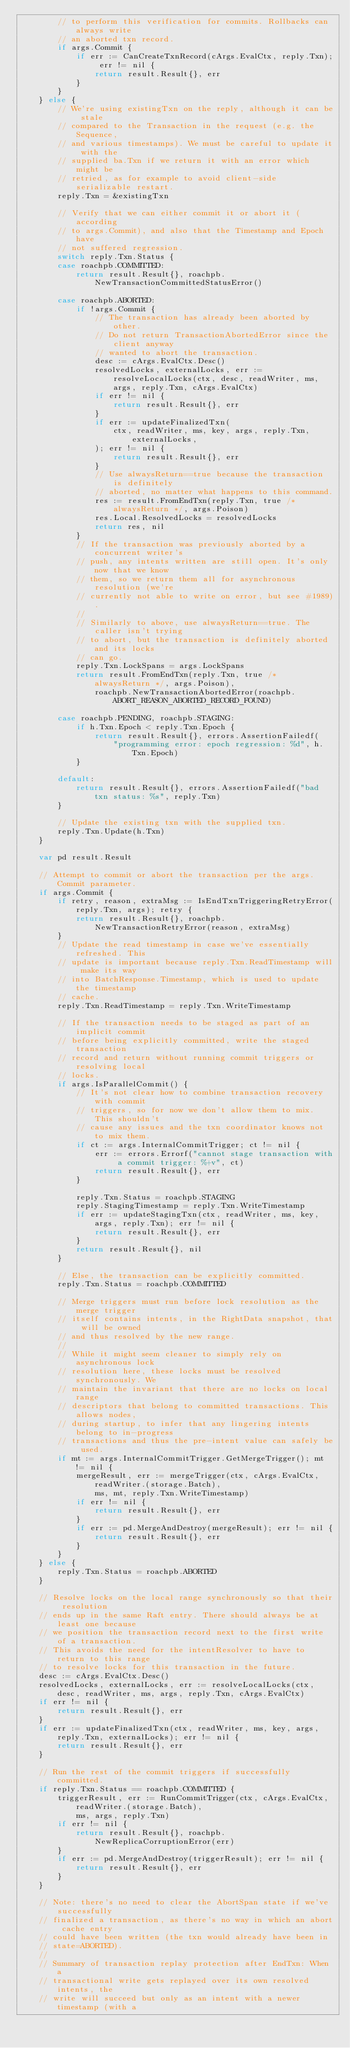<code> <loc_0><loc_0><loc_500><loc_500><_Go_>		// to perform this verification for commits. Rollbacks can always write
		// an aborted txn record.
		if args.Commit {
			if err := CanCreateTxnRecord(cArgs.EvalCtx, reply.Txn); err != nil {
				return result.Result{}, err
			}
		}
	} else {
		// We're using existingTxn on the reply, although it can be stale
		// compared to the Transaction in the request (e.g. the Sequence,
		// and various timestamps). We must be careful to update it with the
		// supplied ba.Txn if we return it with an error which might be
		// retried, as for example to avoid client-side serializable restart.
		reply.Txn = &existingTxn

		// Verify that we can either commit it or abort it (according
		// to args.Commit), and also that the Timestamp and Epoch have
		// not suffered regression.
		switch reply.Txn.Status {
		case roachpb.COMMITTED:
			return result.Result{}, roachpb.NewTransactionCommittedStatusError()

		case roachpb.ABORTED:
			if !args.Commit {
				// The transaction has already been aborted by other.
				// Do not return TransactionAbortedError since the client anyway
				// wanted to abort the transaction.
				desc := cArgs.EvalCtx.Desc()
				resolvedLocks, externalLocks, err := resolveLocalLocks(ctx, desc, readWriter, ms, args, reply.Txn, cArgs.EvalCtx)
				if err != nil {
					return result.Result{}, err
				}
				if err := updateFinalizedTxn(
					ctx, readWriter, ms, key, args, reply.Txn, externalLocks,
				); err != nil {
					return result.Result{}, err
				}
				// Use alwaysReturn==true because the transaction is definitely
				// aborted, no matter what happens to this command.
				res := result.FromEndTxn(reply.Txn, true /* alwaysReturn */, args.Poison)
				res.Local.ResolvedLocks = resolvedLocks
				return res, nil
			}
			// If the transaction was previously aborted by a concurrent writer's
			// push, any intents written are still open. It's only now that we know
			// them, so we return them all for asynchronous resolution (we're
			// currently not able to write on error, but see #1989).
			//
			// Similarly to above, use alwaysReturn==true. The caller isn't trying
			// to abort, but the transaction is definitely aborted and its locks
			// can go.
			reply.Txn.LockSpans = args.LockSpans
			return result.FromEndTxn(reply.Txn, true /* alwaysReturn */, args.Poison),
				roachpb.NewTransactionAbortedError(roachpb.ABORT_REASON_ABORTED_RECORD_FOUND)

		case roachpb.PENDING, roachpb.STAGING:
			if h.Txn.Epoch < reply.Txn.Epoch {
				return result.Result{}, errors.AssertionFailedf(
					"programming error: epoch regression: %d", h.Txn.Epoch)
			}

		default:
			return result.Result{}, errors.AssertionFailedf("bad txn status: %s", reply.Txn)
		}

		// Update the existing txn with the supplied txn.
		reply.Txn.Update(h.Txn)
	}

	var pd result.Result

	// Attempt to commit or abort the transaction per the args.Commit parameter.
	if args.Commit {
		if retry, reason, extraMsg := IsEndTxnTriggeringRetryError(reply.Txn, args); retry {
			return result.Result{}, roachpb.NewTransactionRetryError(reason, extraMsg)
		}
		// Update the read timestamp in case we've essentially refreshed. This
		// update is important because reply.Txn.ReadTimestamp will make its way
		// into BatchResponse.Timestamp, which is used to update the timestamp
		// cache.
		reply.Txn.ReadTimestamp = reply.Txn.WriteTimestamp

		// If the transaction needs to be staged as part of an implicit commit
		// before being explicitly committed, write the staged transaction
		// record and return without running commit triggers or resolving local
		// locks.
		if args.IsParallelCommit() {
			// It's not clear how to combine transaction recovery with commit
			// triggers, so for now we don't allow them to mix. This shouldn't
			// cause any issues and the txn coordinator knows not to mix them.
			if ct := args.InternalCommitTrigger; ct != nil {
				err := errors.Errorf("cannot stage transaction with a commit trigger: %+v", ct)
				return result.Result{}, err
			}

			reply.Txn.Status = roachpb.STAGING
			reply.StagingTimestamp = reply.Txn.WriteTimestamp
			if err := updateStagingTxn(ctx, readWriter, ms, key, args, reply.Txn); err != nil {
				return result.Result{}, err
			}
			return result.Result{}, nil
		}

		// Else, the transaction can be explicitly committed.
		reply.Txn.Status = roachpb.COMMITTED

		// Merge triggers must run before lock resolution as the merge trigger
		// itself contains intents, in the RightData snapshot, that will be owned
		// and thus resolved by the new range.
		//
		// While it might seem cleaner to simply rely on asynchronous lock
		// resolution here, these locks must be resolved synchronously. We
		// maintain the invariant that there are no locks on local range
		// descriptors that belong to committed transactions. This allows nodes,
		// during startup, to infer that any lingering intents belong to in-progress
		// transactions and thus the pre-intent value can safely be used.
		if mt := args.InternalCommitTrigger.GetMergeTrigger(); mt != nil {
			mergeResult, err := mergeTrigger(ctx, cArgs.EvalCtx, readWriter.(storage.Batch),
				ms, mt, reply.Txn.WriteTimestamp)
			if err != nil {
				return result.Result{}, err
			}
			if err := pd.MergeAndDestroy(mergeResult); err != nil {
				return result.Result{}, err
			}
		}
	} else {
		reply.Txn.Status = roachpb.ABORTED
	}

	// Resolve locks on the local range synchronously so that their resolution
	// ends up in the same Raft entry. There should always be at least one because
	// we position the transaction record next to the first write of a transaction.
	// This avoids the need for the intentResolver to have to return to this range
	// to resolve locks for this transaction in the future.
	desc := cArgs.EvalCtx.Desc()
	resolvedLocks, externalLocks, err := resolveLocalLocks(ctx, desc, readWriter, ms, args, reply.Txn, cArgs.EvalCtx)
	if err != nil {
		return result.Result{}, err
	}
	if err := updateFinalizedTxn(ctx, readWriter, ms, key, args, reply.Txn, externalLocks); err != nil {
		return result.Result{}, err
	}

	// Run the rest of the commit triggers if successfully committed.
	if reply.Txn.Status == roachpb.COMMITTED {
		triggerResult, err := RunCommitTrigger(ctx, cArgs.EvalCtx, readWriter.(storage.Batch),
			ms, args, reply.Txn)
		if err != nil {
			return result.Result{}, roachpb.NewReplicaCorruptionError(err)
		}
		if err := pd.MergeAndDestroy(triggerResult); err != nil {
			return result.Result{}, err
		}
	}

	// Note: there's no need to clear the AbortSpan state if we've successfully
	// finalized a transaction, as there's no way in which an abort cache entry
	// could have been written (the txn would already have been in
	// state=ABORTED).
	//
	// Summary of transaction replay protection after EndTxn: When a
	// transactional write gets replayed over its own resolved intents, the
	// write will succeed but only as an intent with a newer timestamp (with a</code> 